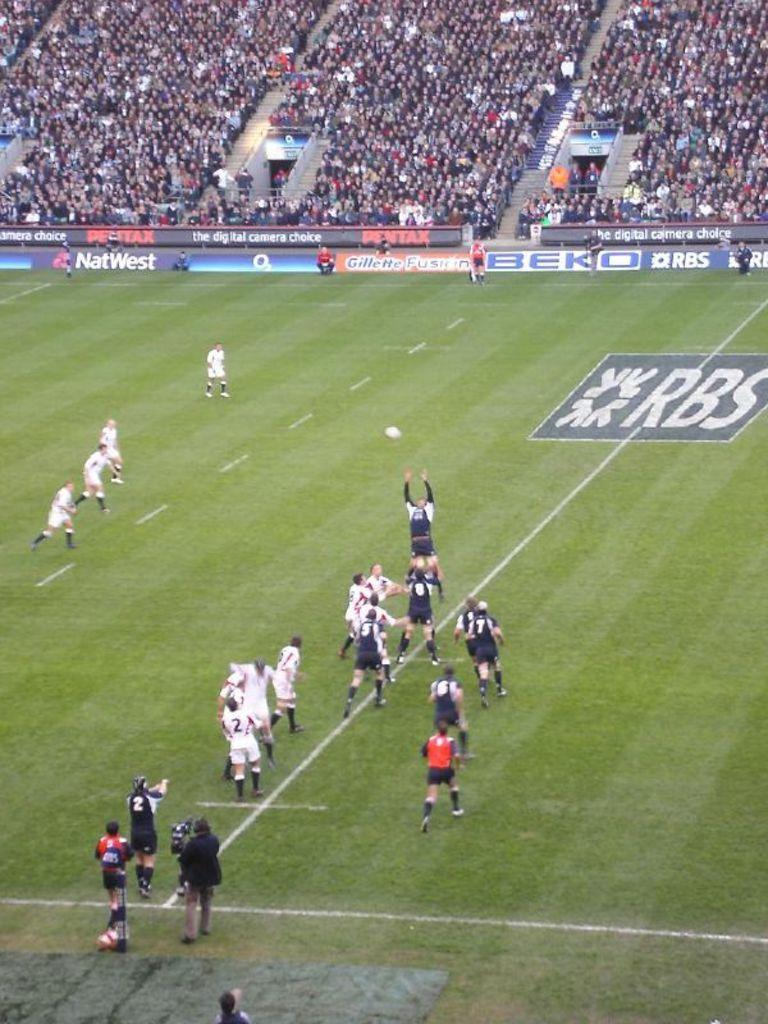<image>
Provide a brief description of the given image. Players standing on a soccer pitch sponsored by RBS 